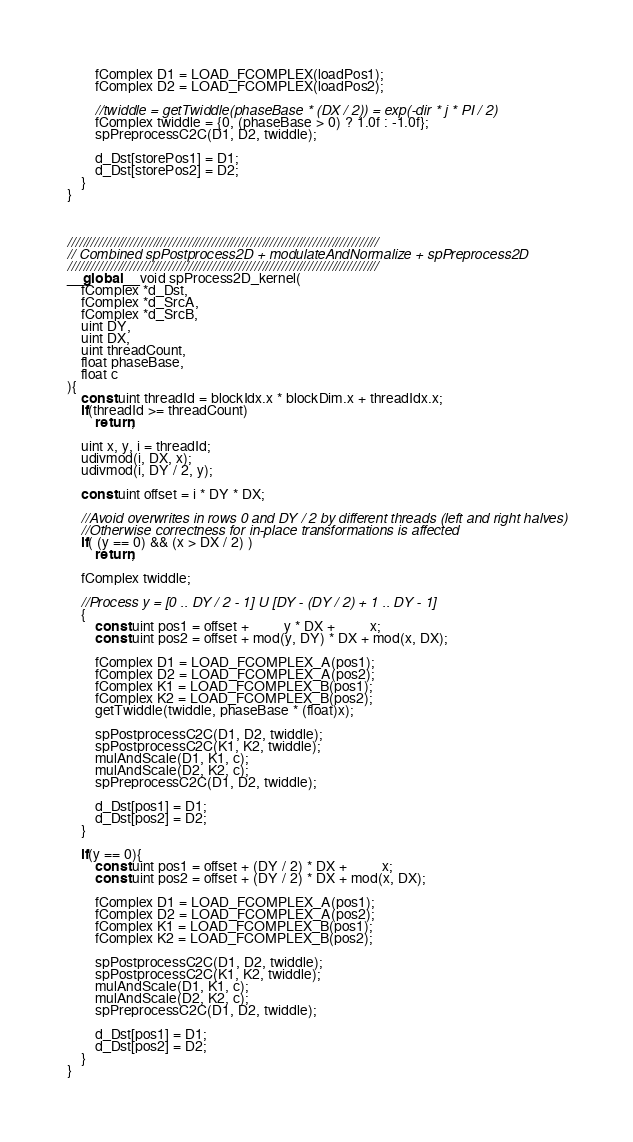Convert code to text. <code><loc_0><loc_0><loc_500><loc_500><_Cuda_>
        fComplex D1 = LOAD_FCOMPLEX(loadPos1);
        fComplex D2 = LOAD_FCOMPLEX(loadPos2);

        //twiddle = getTwiddle(phaseBase * (DX / 2)) = exp(-dir * j * PI / 2)
        fComplex twiddle = {0, (phaseBase > 0) ? 1.0f : -1.0f};
        spPreprocessC2C(D1, D2, twiddle);

        d_Dst[storePos1] = D1;
        d_Dst[storePos2] = D2;
    }
}



////////////////////////////////////////////////////////////////////////////////
// Combined spPostprocess2D + modulateAndNormalize + spPreprocess2D
////////////////////////////////////////////////////////////////////////////////
__global__ void spProcess2D_kernel(
    fComplex *d_Dst,
    fComplex *d_SrcA,
    fComplex *d_SrcB,
    uint DY,
    uint DX,
    uint threadCount,
    float phaseBase,
    float c
){
    const uint threadId = blockIdx.x * blockDim.x + threadIdx.x;
    if(threadId >= threadCount)
        return;

    uint x, y, i = threadId;
    udivmod(i, DX, x);
    udivmod(i, DY / 2, y);

    const uint offset = i * DY * DX;

    //Avoid overwrites in rows 0 and DY / 2 by different threads (left and right halves)
    //Otherwise correctness for in-place transformations is affected
    if( (y == 0) && (x > DX / 2) )
        return;

    fComplex twiddle;

    //Process y = [0 .. DY / 2 - 1] U [DY - (DY / 2) + 1 .. DY - 1]
    {
        const uint pos1 = offset +          y * DX +          x;
        const uint pos2 = offset + mod(y, DY) * DX + mod(x, DX);

        fComplex D1 = LOAD_FCOMPLEX_A(pos1);
        fComplex D2 = LOAD_FCOMPLEX_A(pos2);
        fComplex K1 = LOAD_FCOMPLEX_B(pos1);
        fComplex K2 = LOAD_FCOMPLEX_B(pos2);
        getTwiddle(twiddle, phaseBase * (float)x);

        spPostprocessC2C(D1, D2, twiddle);
        spPostprocessC2C(K1, K2, twiddle);
        mulAndScale(D1, K1, c);
        mulAndScale(D2, K2, c);
        spPreprocessC2C(D1, D2, twiddle);

        d_Dst[pos1] = D1;
        d_Dst[pos2] = D2;
    }

    if(y == 0){
        const uint pos1 = offset + (DY / 2) * DX +          x;
        const uint pos2 = offset + (DY / 2) * DX + mod(x, DX);

        fComplex D1 = LOAD_FCOMPLEX_A(pos1);
        fComplex D2 = LOAD_FCOMPLEX_A(pos2);
        fComplex K1 = LOAD_FCOMPLEX_B(pos1);
        fComplex K2 = LOAD_FCOMPLEX_B(pos2);

        spPostprocessC2C(D1, D2, twiddle);
        spPostprocessC2C(K1, K2, twiddle);
        mulAndScale(D1, K1, c);
        mulAndScale(D2, K2, c);
        spPreprocessC2C(D1, D2, twiddle);

        d_Dst[pos1] = D1;
        d_Dst[pos2] = D2;
    }
}
</code> 